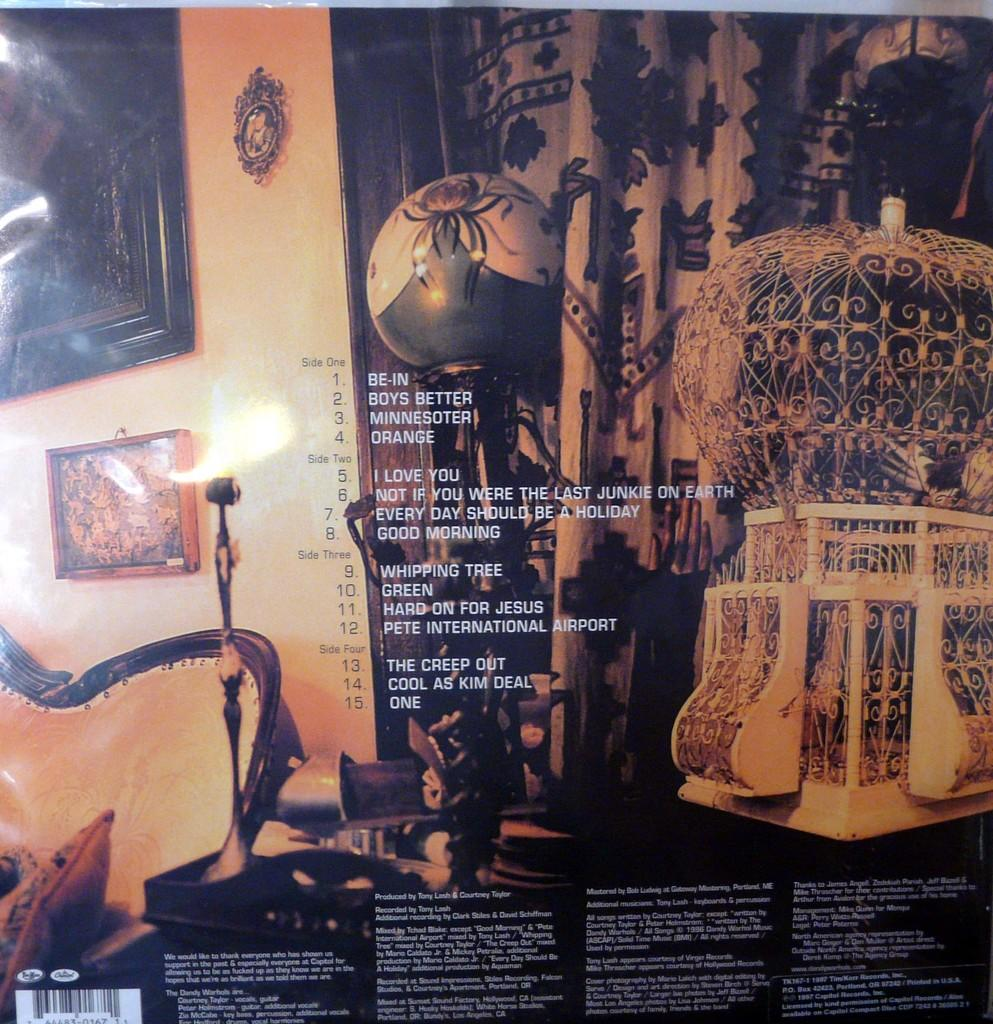<image>
Write a terse but informative summary of the picture. The back of an album showcasing the songs from side one, two, three and four. 